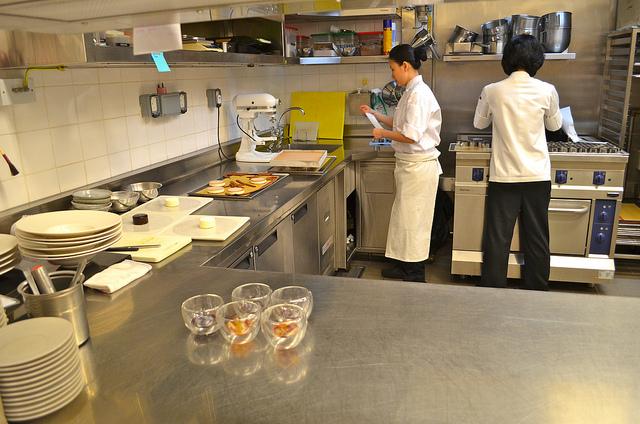How sanitary does the counter look?
Give a very brief answer. Very. How many clear glass bowls are on the counter?
Concise answer only. 5. What is the counter made of?
Write a very short answer. Steel. 